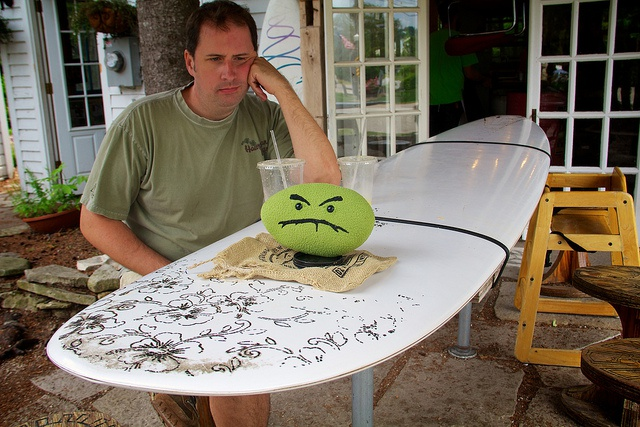Describe the objects in this image and their specific colors. I can see dining table in black, lightgray, darkgray, olive, and gray tones, surfboard in black, lightgray, darkgray, and gray tones, people in black, gray, and brown tones, chair in black, olive, and maroon tones, and sports ball in black, olive, and khaki tones in this image. 